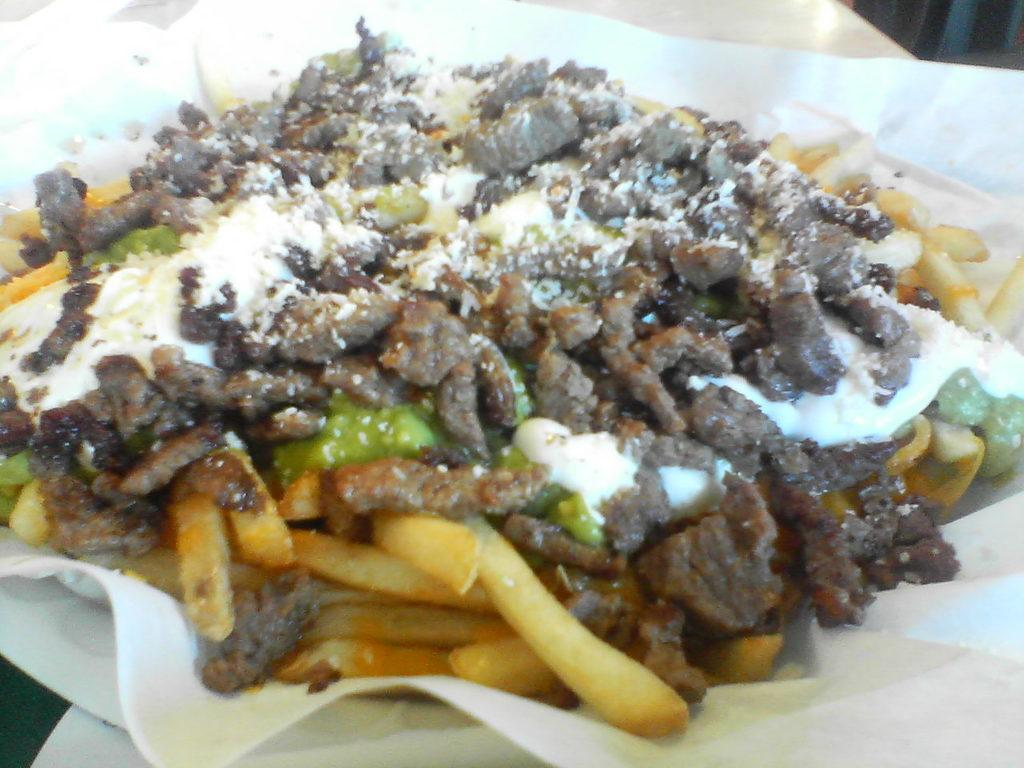What is the main subject of the image? The main subject of the image is a food item on the table. Can you describe the food item in more detail? Unfortunately, the provided facts do not give any specific details about the food item. What else can be seen in the image besides the food item? The provided facts do not mention any other objects or elements in the image. Where is the nest located in the image? There is no nest present in the image. What is the title of the food item in the image? There is no title associated with the food item in the image. 